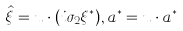Convert formula to latex. <formula><loc_0><loc_0><loc_500><loc_500>\hat { \xi } = { u } \cdot ( i \sigma _ { 2 } { \xi } ^ { * } ) , a ^ { * } = { u } \cdot { a } ^ { * }</formula> 